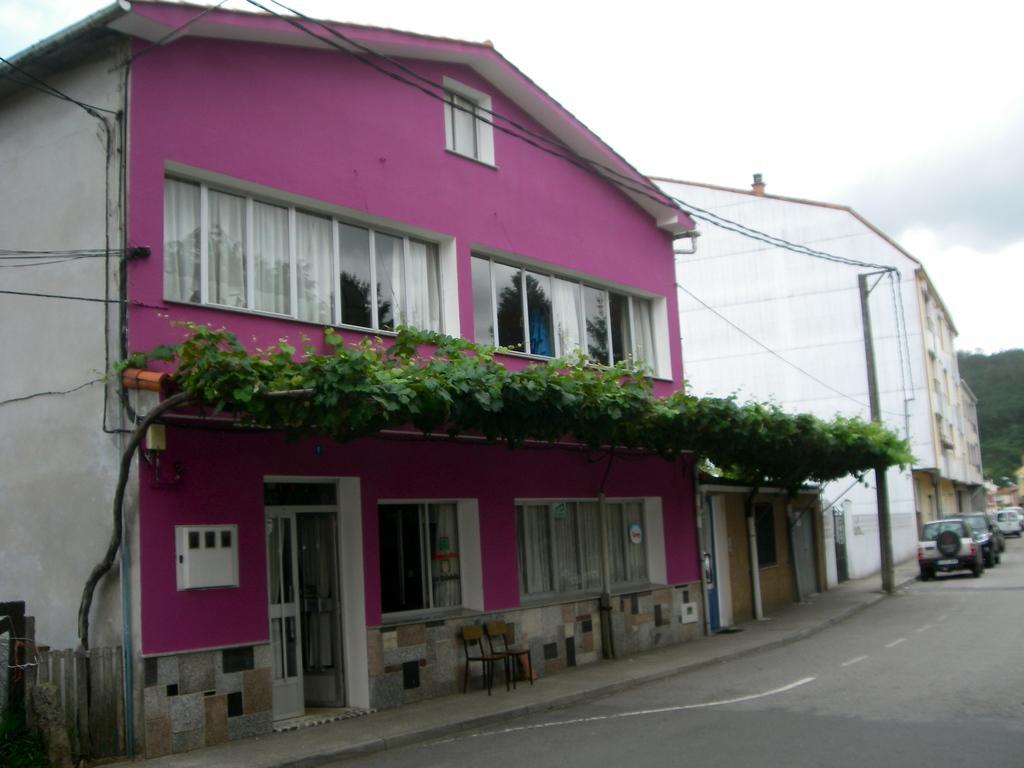In one or two sentences, can you explain what this image depicts? There is a road. On the road there are vehicles. Near to the road there is a sidewalk. On the sidewalk there is an electric pole with wires. There are chairs on the sidewalk. Also there are buildings. On the building there are windows, door. On the building there is a creeper. In the background there is sky. Also there is a fencing near to the building. 